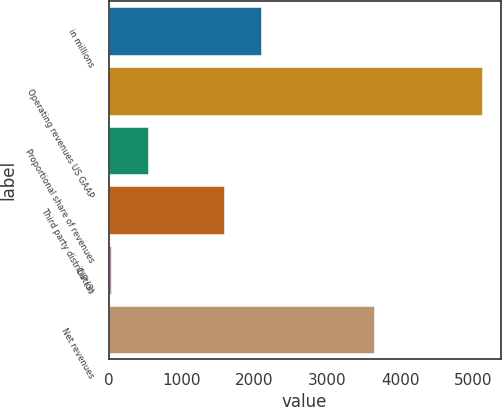<chart> <loc_0><loc_0><loc_500><loc_500><bar_chart><fcel>in millions<fcel>Operating revenues US GAAP<fcel>Proportional share of revenues<fcel>Third party distribution<fcel>CIP (3)<fcel>Net revenues<nl><fcel>2088.27<fcel>5122.9<fcel>547.57<fcel>1579.9<fcel>39.2<fcel>3643.2<nl></chart> 